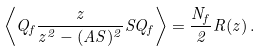<formula> <loc_0><loc_0><loc_500><loc_500>\left \langle Q _ { f } \frac { z } { z ^ { 2 } - ( A S ) ^ { 2 } } S Q _ { f } \right \rangle = \frac { N _ { f } } { 2 } R ( z ) \, .</formula> 